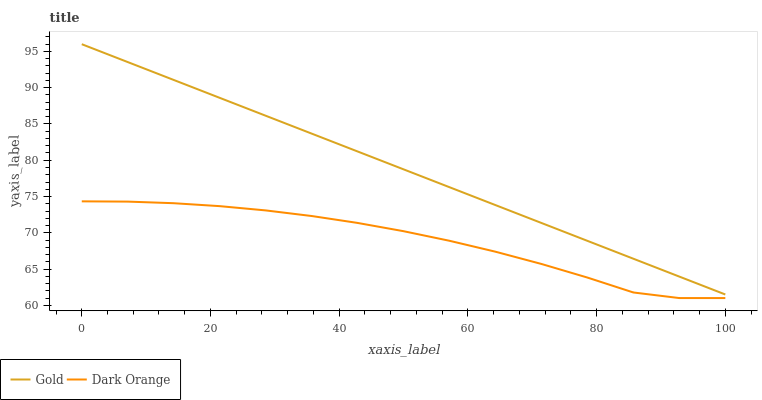Does Dark Orange have the minimum area under the curve?
Answer yes or no. Yes. Does Gold have the maximum area under the curve?
Answer yes or no. Yes. Does Gold have the minimum area under the curve?
Answer yes or no. No. Is Gold the smoothest?
Answer yes or no. Yes. Is Dark Orange the roughest?
Answer yes or no. Yes. Is Gold the roughest?
Answer yes or no. No. Does Dark Orange have the lowest value?
Answer yes or no. Yes. Does Gold have the lowest value?
Answer yes or no. No. Does Gold have the highest value?
Answer yes or no. Yes. Is Dark Orange less than Gold?
Answer yes or no. Yes. Is Gold greater than Dark Orange?
Answer yes or no. Yes. Does Dark Orange intersect Gold?
Answer yes or no. No. 